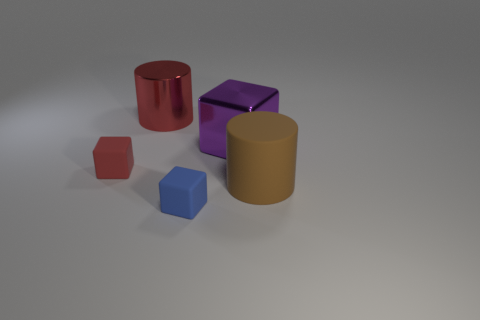Is there a red metal cylinder of the same size as the brown cylinder?
Make the answer very short. Yes. There is a matte object to the left of the small blue matte object; what is its size?
Make the answer very short. Small. There is a cylinder that is on the right side of the purple block; are there any large things on the left side of it?
Provide a succinct answer. Yes. How many other objects are there of the same shape as the brown matte object?
Ensure brevity in your answer.  1. Is the shape of the large brown rubber thing the same as the large purple shiny thing?
Provide a succinct answer. No. The rubber thing that is behind the blue rubber thing and right of the large red cylinder is what color?
Make the answer very short. Brown. There is a matte cube that is the same color as the big metallic cylinder; what size is it?
Ensure brevity in your answer.  Small. How many tiny objects are blocks or brown matte cylinders?
Your answer should be very brief. 2. Is there any other thing that is the same color as the big rubber cylinder?
Offer a very short reply. No. What material is the large cylinder that is to the right of the tiny rubber object that is in front of the cylinder in front of the red metal object?
Give a very brief answer. Rubber. 